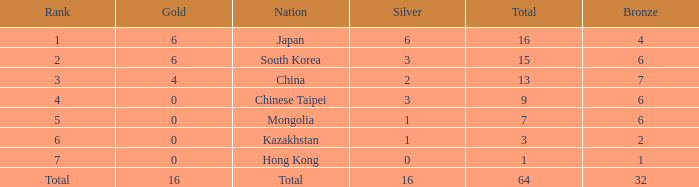Which Nation has a Gold of 0, and a Bronze smaller than 6, and a Rank of 6? Kazakhstan. 